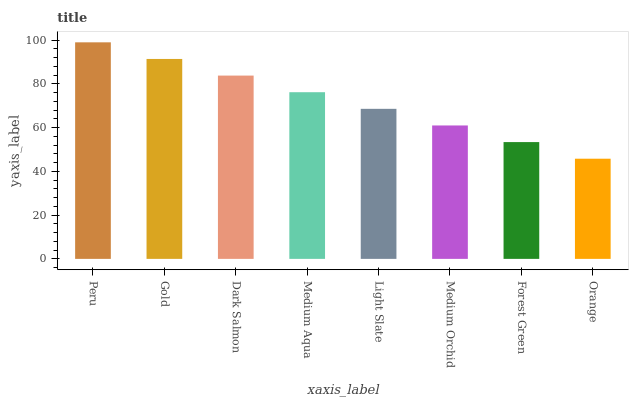Is Orange the minimum?
Answer yes or no. Yes. Is Peru the maximum?
Answer yes or no. Yes. Is Gold the minimum?
Answer yes or no. No. Is Gold the maximum?
Answer yes or no. No. Is Peru greater than Gold?
Answer yes or no. Yes. Is Gold less than Peru?
Answer yes or no. Yes. Is Gold greater than Peru?
Answer yes or no. No. Is Peru less than Gold?
Answer yes or no. No. Is Medium Aqua the high median?
Answer yes or no. Yes. Is Light Slate the low median?
Answer yes or no. Yes. Is Gold the high median?
Answer yes or no. No. Is Forest Green the low median?
Answer yes or no. No. 